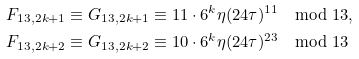Convert formula to latex. <formula><loc_0><loc_0><loc_500><loc_500>F _ { 1 3 , 2 k + 1 } \equiv G _ { 1 3 , 2 k + 1 } & \equiv 1 1 \cdot 6 ^ { k } \eta ( 2 4 \tau ) ^ { 1 1 } \mod 1 3 , \\ F _ { 1 3 , 2 k + 2 } \equiv G _ { 1 3 , 2 k + 2 } & \equiv 1 0 \cdot 6 ^ { k } \eta ( 2 4 \tau ) ^ { 2 3 } \mod 1 3</formula> 